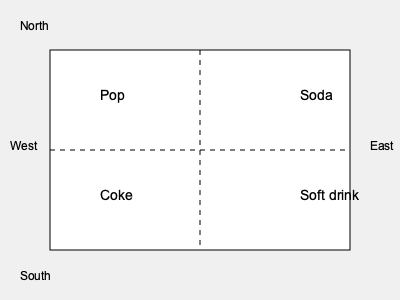Based on the dialect map showing regional variations in terms for carbonated beverages, which term appears to be most prevalent in the Southeastern United States, and how might this linguistic pattern reflect historical and cultural influences in the region? To answer this question, we need to analyze the dialect map and consider the historical and cultural context of the Southeastern United States:

1. Examine the map: The map is divided into four quadrants, each containing a different term for carbonated beverages.

2. Identify the Southeastern region: The Southeast would typically be represented in the bottom-right quadrant of the map.

3. Determine the prevalent term: In the bottom-right quadrant, we see the term "Coke."

4. Historical context: The term "Coke" originates from Coca-Cola, a company founded in Atlanta, Georgia, in 1886.

5. Cultural influence: Coca-Cola's strong presence in the Southeast has led to the genericization of the brand name "Coke" to refer to all carbonated beverages in the region.

6. Linguistic phenomenon: This is an example of a proprietary eponym, where a brand name becomes the generic term for a product category.

7. Social identity: The use of "Coke" as a generic term reflects the strong cultural identification with the Coca-Cola brand in the Southeast.

8. Regional pride: The widespread use of "Coke" can be seen as a form of regional pride and loyalty to a local brand that achieved national and global success.

9. Socioeconomic factors: The prevalence of this term might also reflect the historical economic impact of the Coca-Cola company on the region.

10. Linguistic stratification: The use of "Coke" as a generic term can serve as a linguistic marker, potentially indicating someone's regional origin or cultural background.
Answer: "Coke," reflecting Coca-Cola's historical and cultural influence in the Southeast. 